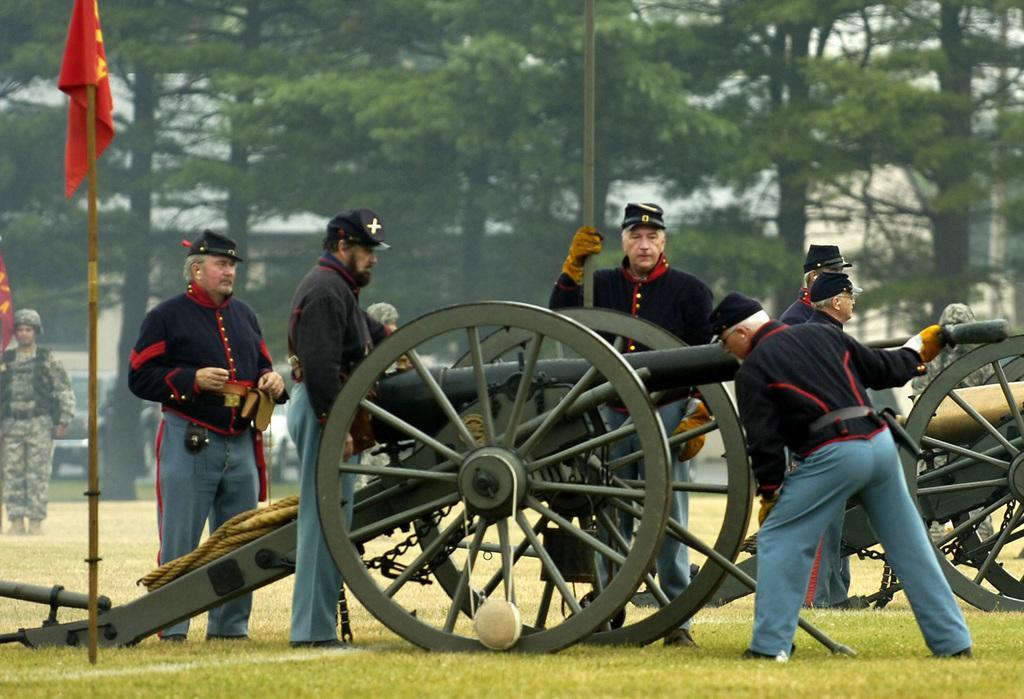Could you give a brief overview of what you see in this image? In this picture we can see some people standing here, at the bottom there is grass, we can see a flag here, in the background there are some trees, we can see a rope here. 